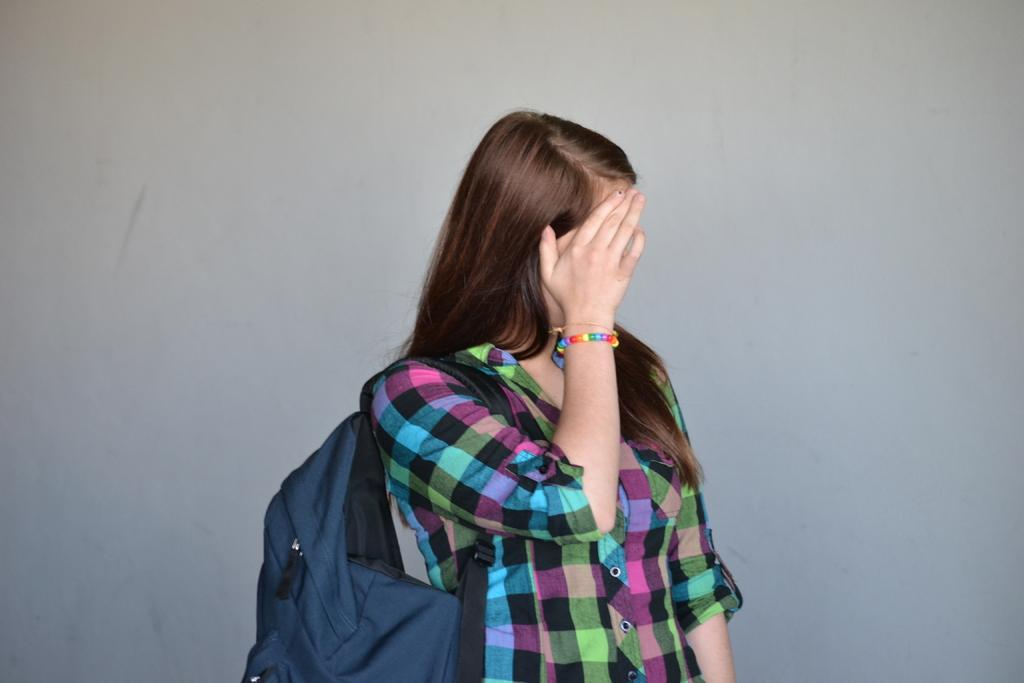Who is the main subject in the image? There is a woman in the image. Can you describe the woman's position in the image? The woman is standing in the front. What is the woman wearing in the image? The woman is wearing a bag. What color is the bag? The bag is blue in color. How does the bag affect the woman's appearance in the image? The bag is hiding the woman's face. What type of twig is the woman holding in the image? There is no twig present in the image; the woman is wearing a blue bag that hides her face. 